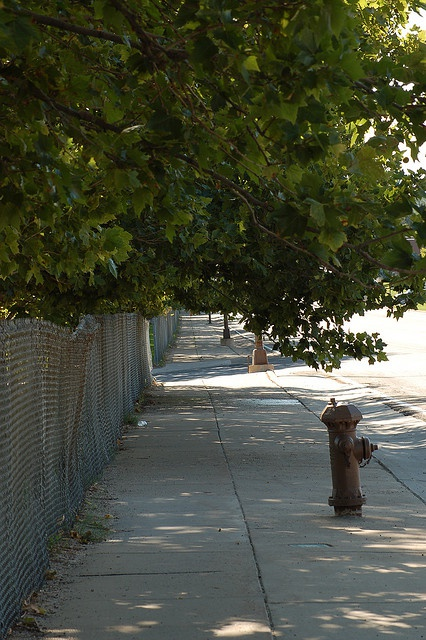Describe the objects in this image and their specific colors. I can see a fire hydrant in black and gray tones in this image. 